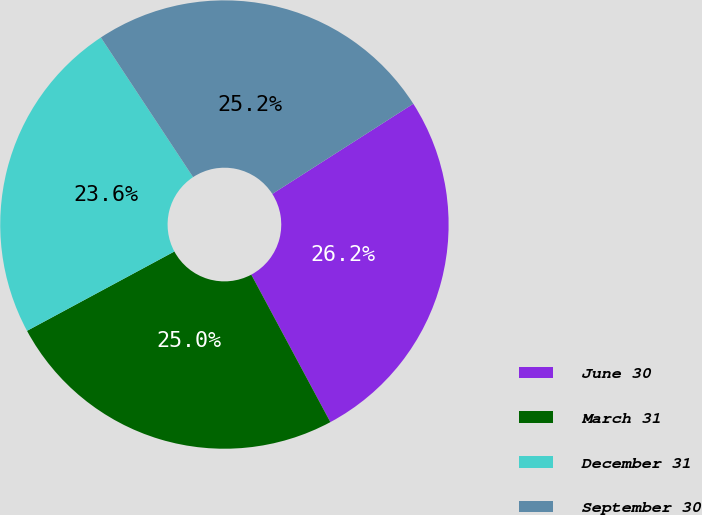Convert chart. <chart><loc_0><loc_0><loc_500><loc_500><pie_chart><fcel>June 30<fcel>March 31<fcel>December 31<fcel>September 30<nl><fcel>26.22%<fcel>24.97%<fcel>23.57%<fcel>25.23%<nl></chart> 